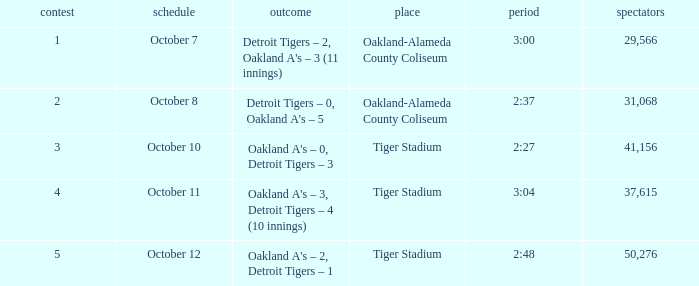What is the number of people in attendance when the time is 3:00? 29566.0. 